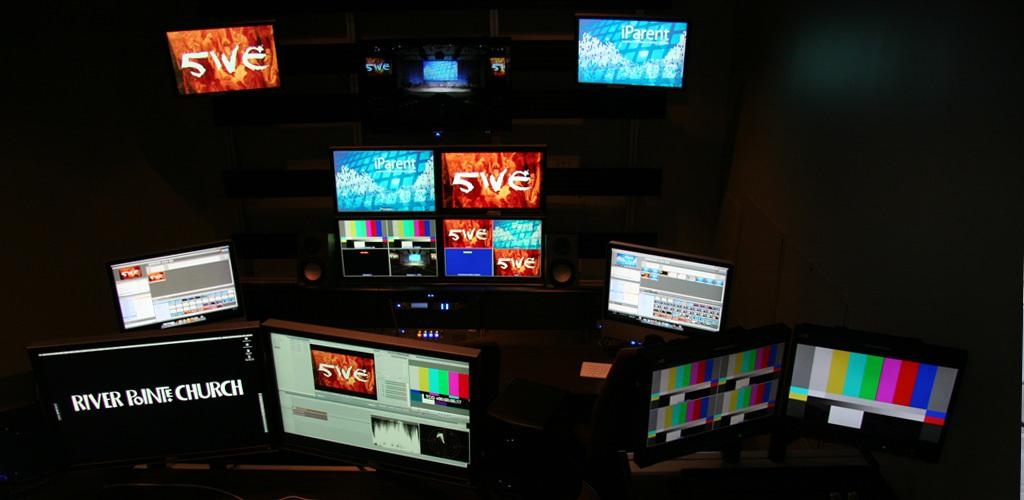<image>
Describe the image concisely. Screen monitors with one saying "River Pointe Church" on it. 